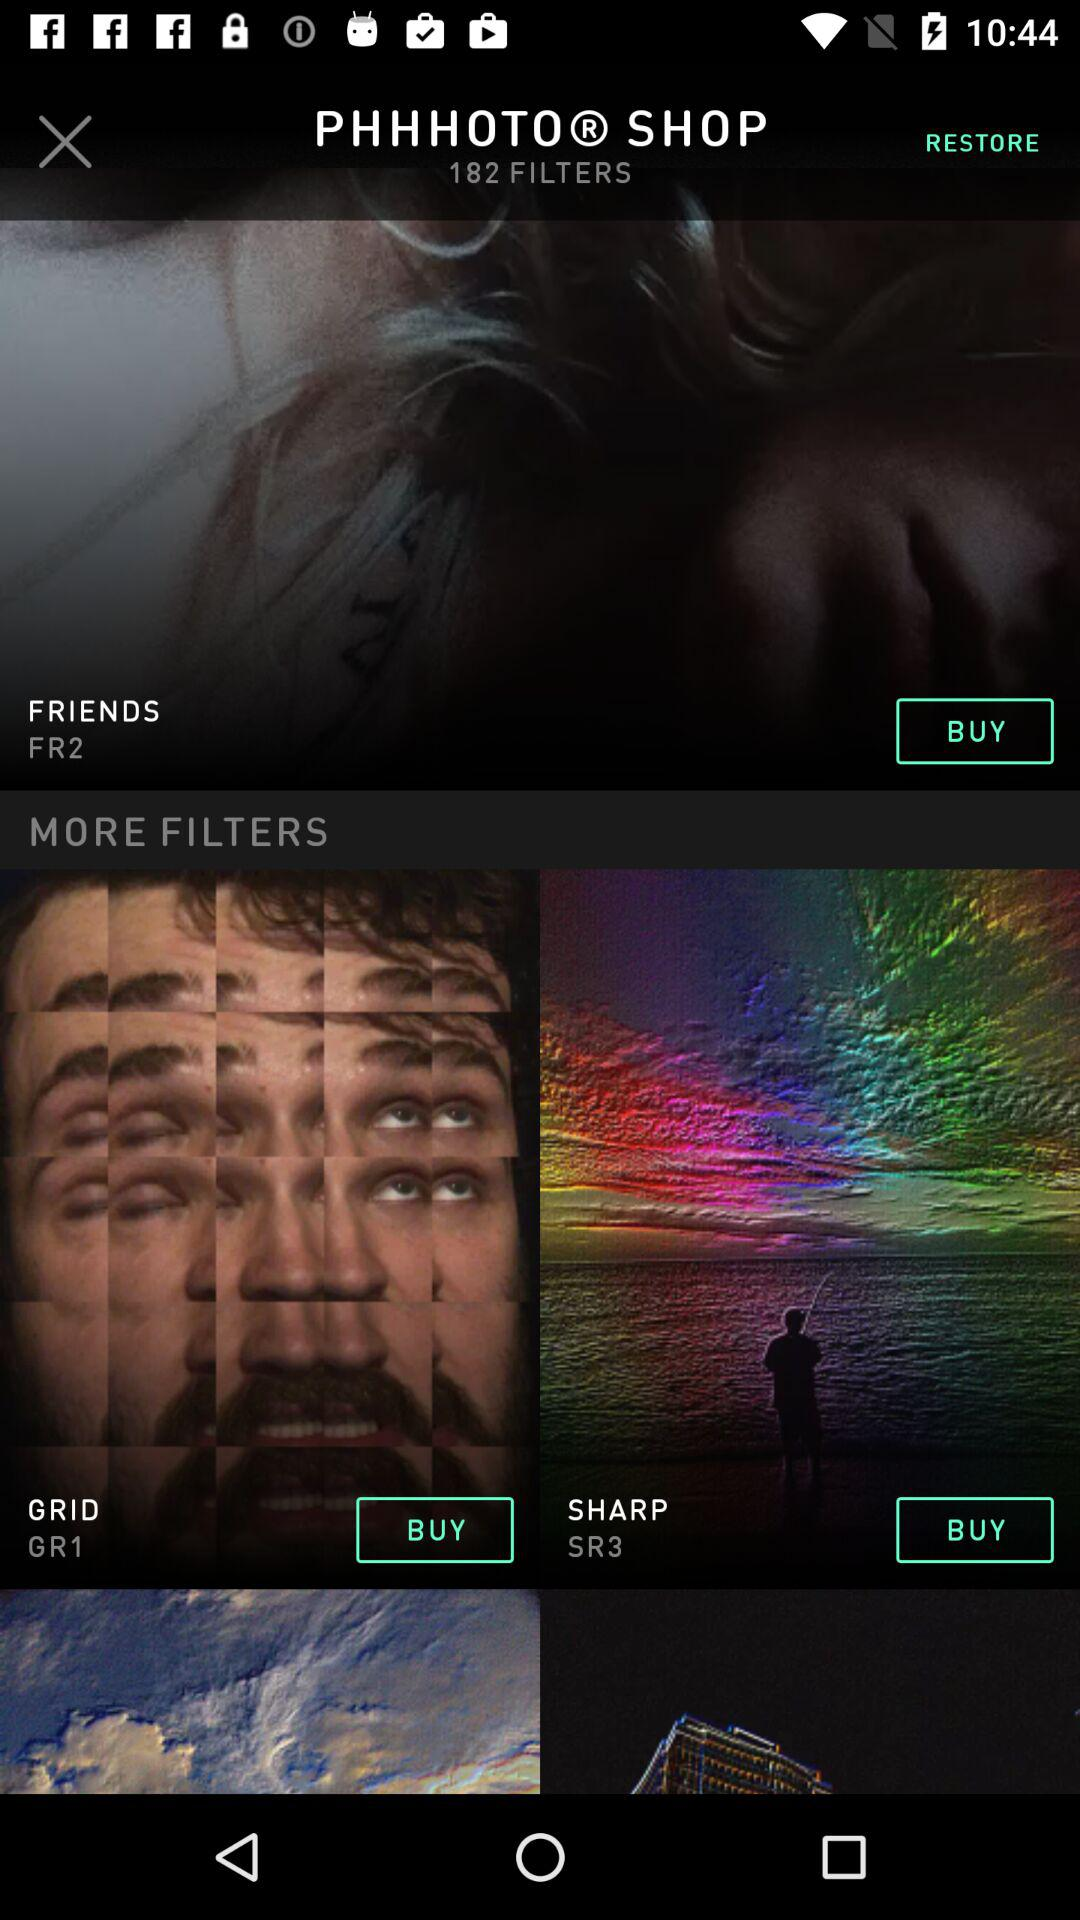How many filters are there in total in "PHHOTOⓇ SHOP"? In "PHHOTOⓇ SHOP", there are a total of 182 filters. 